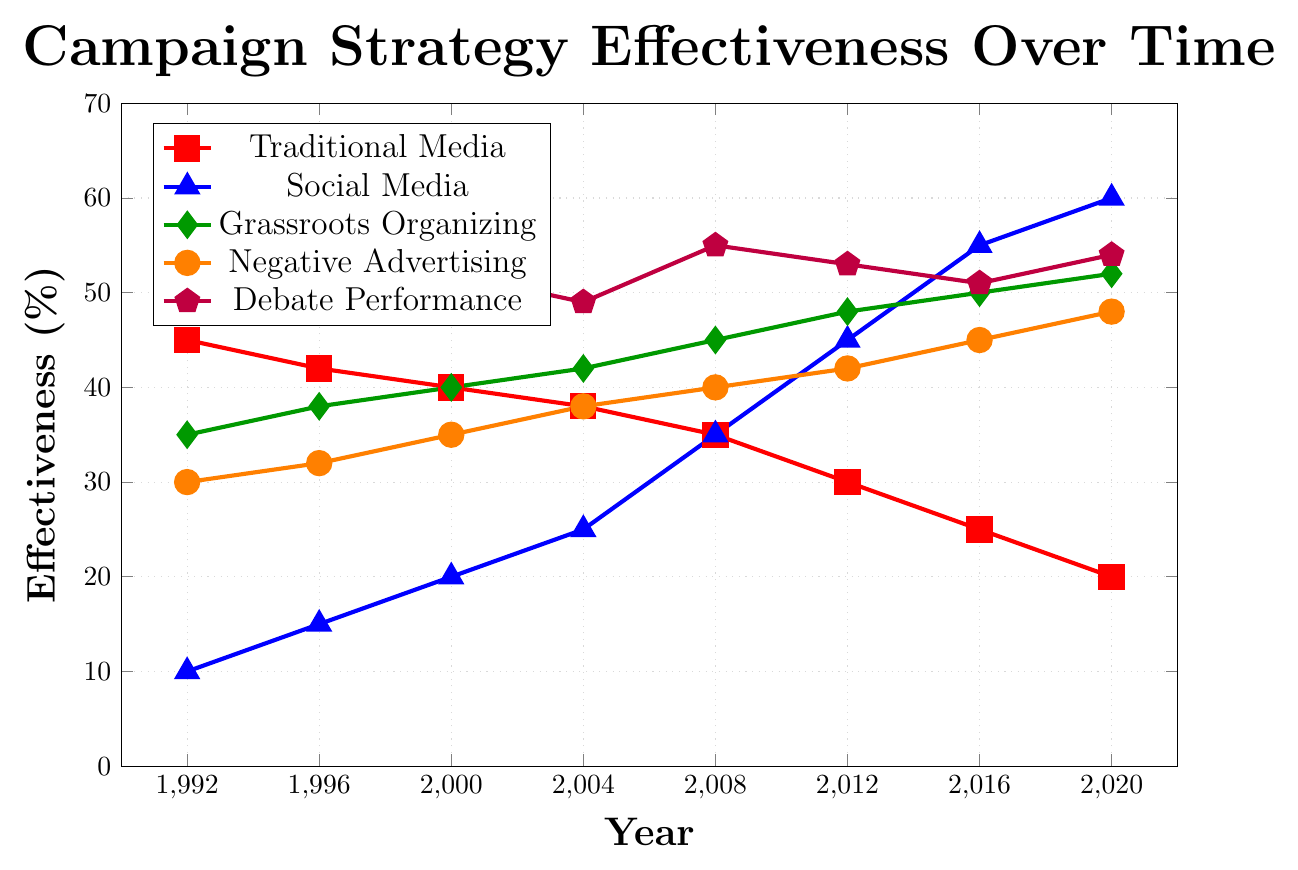What was the effectiveness of "Grassroots Organizing" in the year 2008? Look at the green line (Grassroots Organizing) at the year 2008. The y-value is 45%.
Answer: 45% How did the effectiveness of "Social Media" change from 1992 to 2020? Find the blue line (Social Media) and compare the endpoints at 1992 and 2020. It increased from 10% in 1992 to 60% in 2020.
Answer: It increased by 50% Which campaign strategy was the most effective in 2020? Compare the highest y-values for the year 2020 among all lines. Purple line (Debate Performance) at 54% is the highest.
Answer: Debate Performance By how much did the effectiveness of "Traditional Media" decrease from 1992 to 2016? Find the red line (Traditional Media) for the years 1992 and 2016. The values are 45% in 1992 and 25% in 2016. Calculate 45 - 25.
Answer: 20% Which two campaign strategies roughly intersect in effectiveness around the year 2008? Look for points where the y-values of two different colored lines are close around 2008. Blue line (Social Media) and Orange line (Negative Advertising) intersect around 35% and 40%.
Answer: Social Media and Negative Advertising What is the average effectiveness of "Debate Performance" over the given years? Add the values for Debate Performance in each year: 50 + 48 + 52 + 49 + 55 + 53 + 51 + 54. Divide the sum by the number of values (8). \( (50+48+52+49+55+53+51+54) / 8 \)
Answer: 51.5% What was the effectiveness of "Negative Advertising" in 2012 and how does it compare with "Traditional Media" in the same year? Locate the two points for 2012: Orange line (Negative Advertising) at 42%, Red line (Traditional Media) at 30%. Calculate the difference 42 - 30.
Answer: 12% higher Did "Grassroots Organizing" ever have a higher effectiveness than "Debate Performance"? Compare the green line and purple line. Debate Performance (purple) always has higher values than Grassroots Organizing (green).
Answer: No What is the combined effectiveness of all strategies in the year 2000? Add the y-values from each strategy for 2000: 40 (Traditional Media) + 20 (Social Media) + 40 (Grassroots Organizing) + 35 (Negative Advertising) + 52 (Debate Performance).
Answer: 187% What can be said about the trend of "Traditional Media" over the years? Observe the red line from 1992 to 2020. The effectiveness has steadily decreased from 45% to 20%.
Answer: Steadily decreasing 